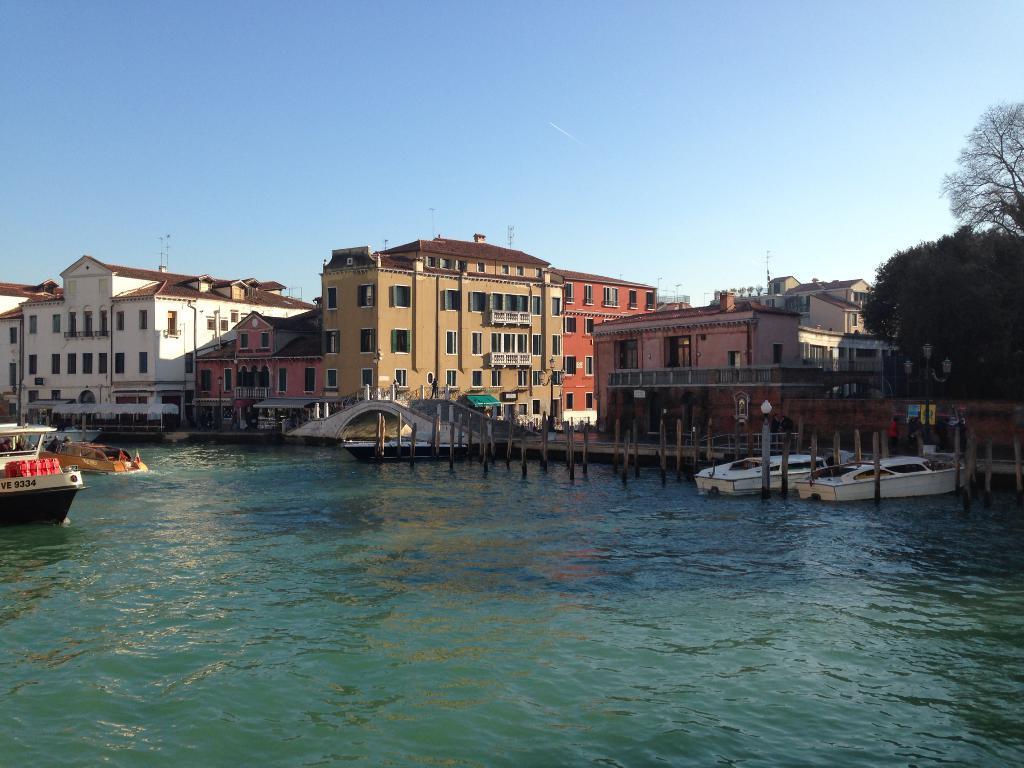Describe this image in one or two sentences. In this picture I can see the boats on the water. I can see the buildings. I can see light poles. I can see trees on the right side. I can see clouds in the sky. 